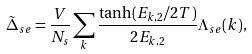<formula> <loc_0><loc_0><loc_500><loc_500>\tilde { \Delta } _ { s e } = \frac { V } { N _ { s } } \sum _ { k } \frac { \tanh ( E _ { { k } , 2 } / 2 T ) } { 2 E _ { { k } , 2 } } \Lambda _ { s e } ( { k } ) ,</formula> 